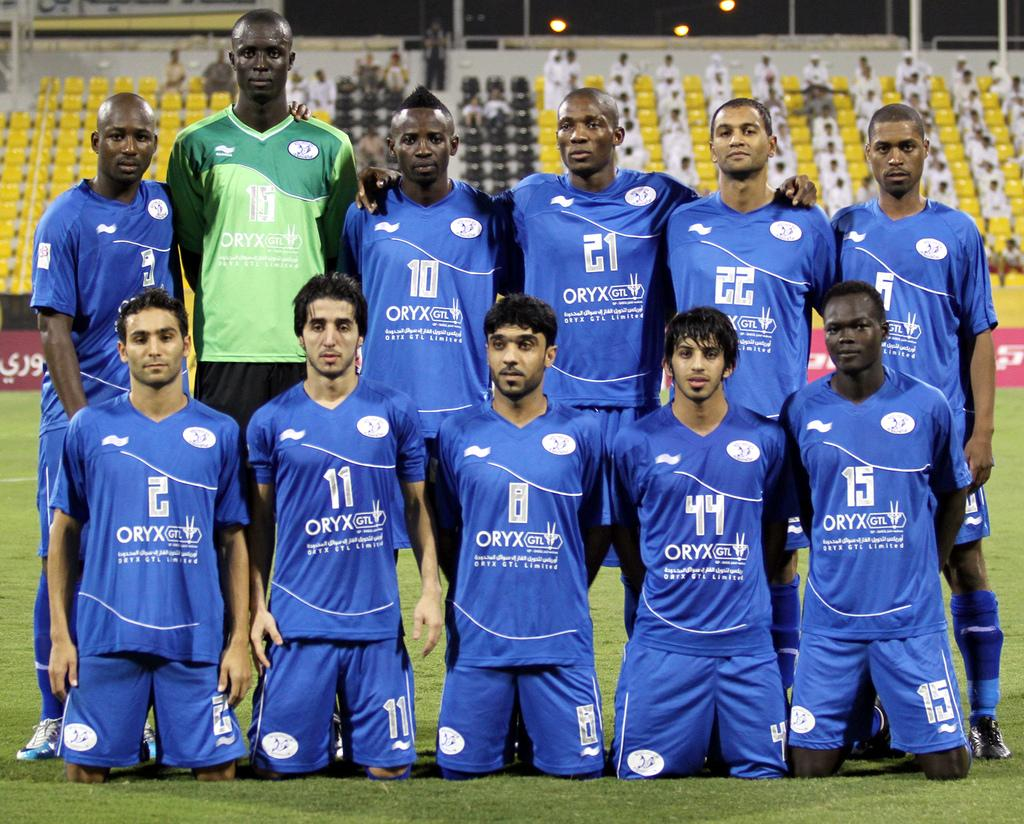<image>
Share a concise interpretation of the image provided. A sports team is posing together for a group photo with ORYX on their shirts. 